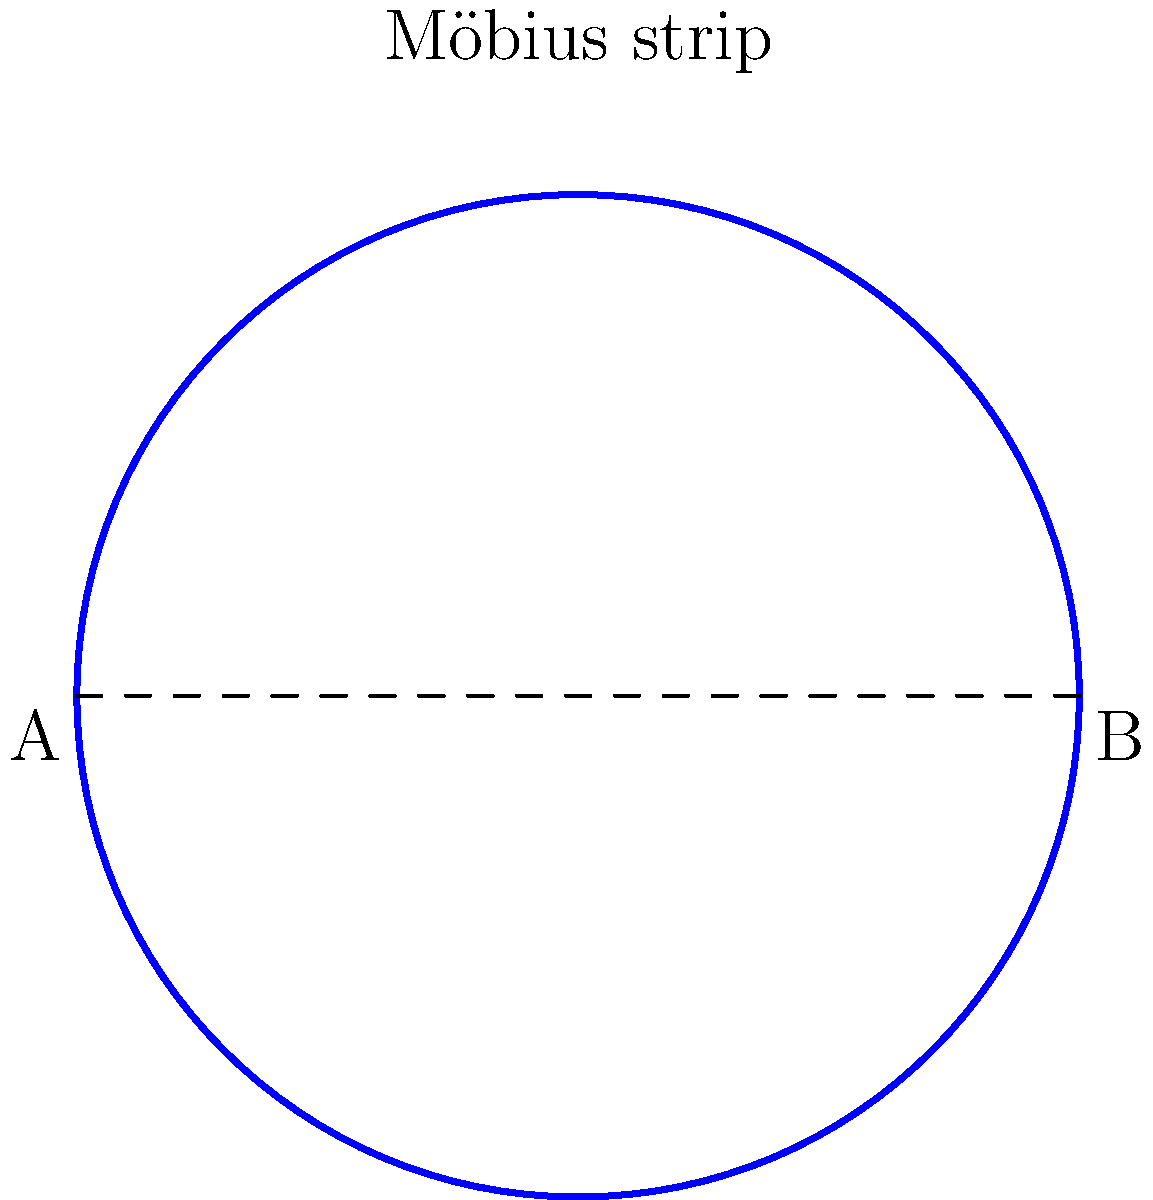How might the topological properties of a Möbius strip inspire a unique costume design for a futuristic period drama? Consider the strip's continuous surface and its potential application in creating a seamless, flowing garment that appears to have no clear beginning or end. To answer this question, let's break down the properties of a Möbius strip and how they can be applied to costume design:

1. Single surface: A Möbius strip has only one side and one edge, despite appearing to have two surfaces.
   - In costume design, this could inspire a garment that seamlessly transitions from the outer layer to the inner layer without a clear distinction.

2. Non-orientability: You can trace the entire surface without lifting your finger or crossing an edge.
   - This property could be used to create a continuous, flowing design that wraps around the body in unexpected ways.

3. Topological curiosity: Cutting a Möbius strip along its center line results in one longer loop instead of two separate bands.
   - This could inspire a costume with transformative elements, where parts of the garment can be unzipped or unfastened to change its shape dramatically.

4. Infinite loop: The surface of a Möbius strip has no beginning or end.
   - This concept could be applied to create a costume with repeating patterns or textures that seem to flow endlessly around the body.

5. Twist: The defining characteristic of a Möbius strip is its half-twist.
   - In costume design, this could be interpreted as asymmetrical elements or unexpected twists in the fabric that create visual interest.

To incorporate these ideas into a futuristic period drama costume:
- Use lightweight, flowing fabrics that can be manipulated to create continuous surfaces.
- Incorporate hidden seams or fastenings that allow the garment to transform or be worn in multiple ways.
- Design patterns or textures that flow seamlessly from one part of the costume to another, creating an illusion of infinity.
- Utilize asymmetrical cuts and draping techniques to mimic the twist of a Möbius strip.
- Consider using modern materials with a period-inspired silhouette to blend futuristic elements with historical aesthetics.
Answer: A costume with seamless transitions, transformative elements, infinite patterns, and asymmetrical twists inspired by Möbius strip properties. 